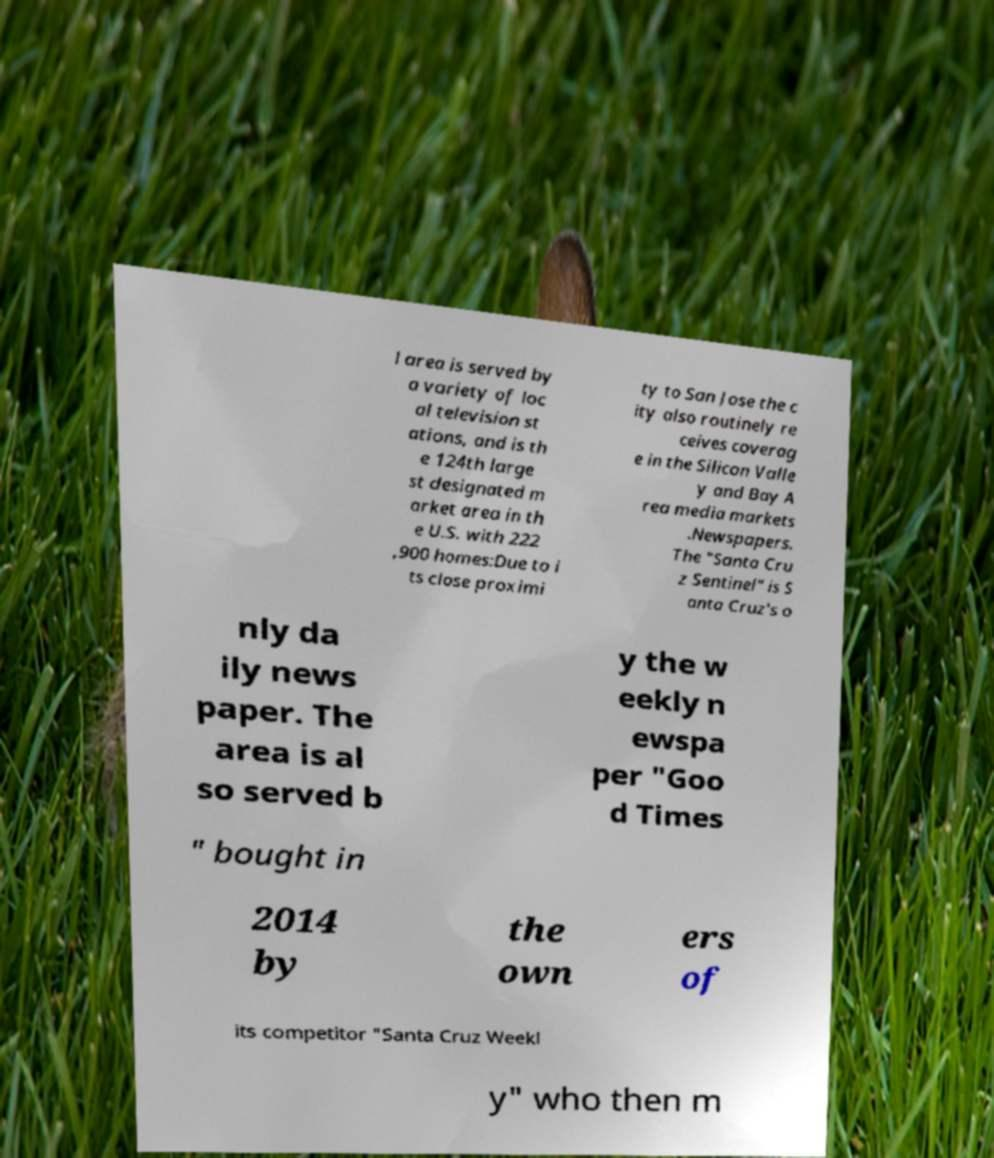Please read and relay the text visible in this image. What does it say? l area is served by a variety of loc al television st ations, and is th e 124th large st designated m arket area in th e U.S. with 222 ,900 homes:Due to i ts close proximi ty to San Jose the c ity also routinely re ceives coverag e in the Silicon Valle y and Bay A rea media markets .Newspapers. The "Santa Cru z Sentinel" is S anta Cruz's o nly da ily news paper. The area is al so served b y the w eekly n ewspa per "Goo d Times " bought in 2014 by the own ers of its competitor "Santa Cruz Weekl y" who then m 